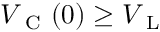<formula> <loc_0><loc_0><loc_500><loc_500>V _ { C } ( 0 ) \geq V _ { L }</formula> 